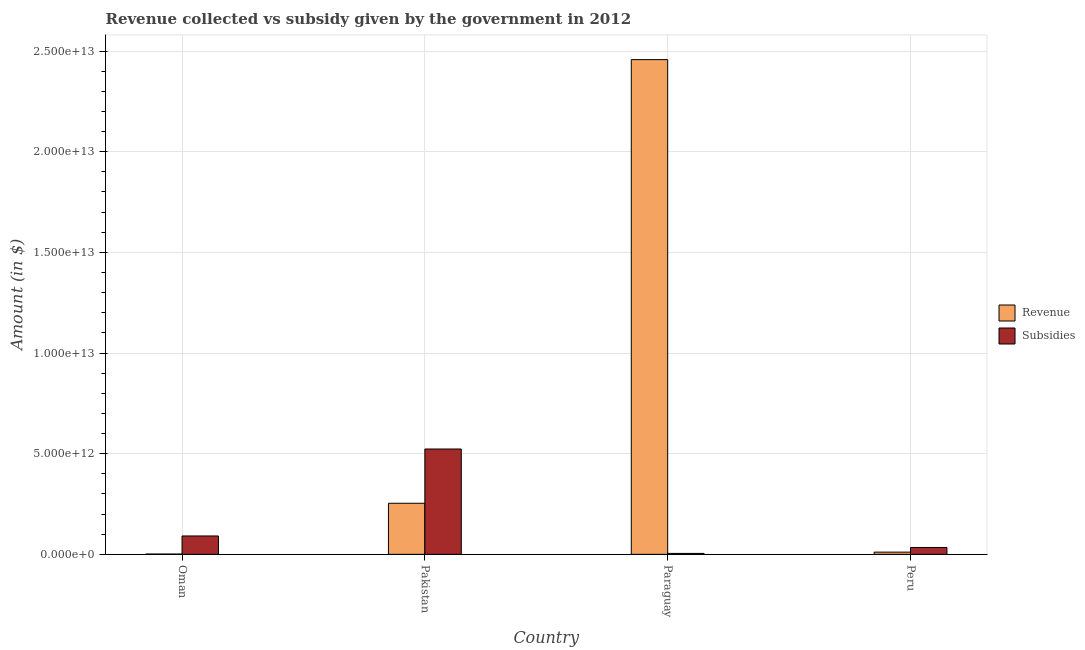Are the number of bars per tick equal to the number of legend labels?
Provide a succinct answer. Yes. What is the label of the 2nd group of bars from the left?
Provide a short and direct response. Pakistan. In how many cases, is the number of bars for a given country not equal to the number of legend labels?
Give a very brief answer. 0. What is the amount of revenue collected in Oman?
Your response must be concise. 1.34e+1. Across all countries, what is the maximum amount of subsidies given?
Offer a terse response. 5.23e+12. Across all countries, what is the minimum amount of revenue collected?
Make the answer very short. 1.34e+1. In which country was the amount of revenue collected maximum?
Your answer should be compact. Paraguay. In which country was the amount of subsidies given minimum?
Give a very brief answer. Paraguay. What is the total amount of subsidies given in the graph?
Provide a succinct answer. 6.53e+12. What is the difference between the amount of subsidies given in Paraguay and that in Peru?
Make the answer very short. -2.96e+11. What is the difference between the amount of revenue collected in Paraguay and the amount of subsidies given in Peru?
Your response must be concise. 2.42e+13. What is the average amount of subsidies given per country?
Offer a very short reply. 1.63e+12. What is the difference between the amount of revenue collected and amount of subsidies given in Oman?
Your answer should be compact. -8.99e+11. In how many countries, is the amount of revenue collected greater than 15000000000000 $?
Your answer should be compact. 1. What is the ratio of the amount of subsidies given in Paraguay to that in Peru?
Your answer should be compact. 0.13. Is the amount of subsidies given in Paraguay less than that in Peru?
Provide a short and direct response. Yes. What is the difference between the highest and the second highest amount of revenue collected?
Provide a short and direct response. 2.20e+13. What is the difference between the highest and the lowest amount of subsidies given?
Offer a very short reply. 5.19e+12. What does the 1st bar from the left in Oman represents?
Your response must be concise. Revenue. What does the 1st bar from the right in Paraguay represents?
Make the answer very short. Subsidies. How many bars are there?
Keep it short and to the point. 8. How many countries are there in the graph?
Make the answer very short. 4. What is the difference between two consecutive major ticks on the Y-axis?
Provide a succinct answer. 5.00e+12. Does the graph contain any zero values?
Make the answer very short. No. How many legend labels are there?
Make the answer very short. 2. How are the legend labels stacked?
Provide a short and direct response. Vertical. What is the title of the graph?
Your answer should be compact. Revenue collected vs subsidy given by the government in 2012. Does "Nonresident" appear as one of the legend labels in the graph?
Provide a short and direct response. No. What is the label or title of the X-axis?
Ensure brevity in your answer.  Country. What is the label or title of the Y-axis?
Keep it short and to the point. Amount (in $). What is the Amount (in $) of Revenue in Oman?
Your answer should be compact. 1.34e+1. What is the Amount (in $) in Subsidies in Oman?
Your answer should be very brief. 9.13e+11. What is the Amount (in $) in Revenue in Pakistan?
Your answer should be very brief. 2.54e+12. What is the Amount (in $) in Subsidies in Pakistan?
Give a very brief answer. 5.23e+12. What is the Amount (in $) of Revenue in Paraguay?
Give a very brief answer. 2.46e+13. What is the Amount (in $) of Subsidies in Paraguay?
Your response must be concise. 4.53e+1. What is the Amount (in $) in Revenue in Peru?
Your answer should be compact. 1.09e+11. What is the Amount (in $) in Subsidies in Peru?
Ensure brevity in your answer.  3.41e+11. Across all countries, what is the maximum Amount (in $) in Revenue?
Give a very brief answer. 2.46e+13. Across all countries, what is the maximum Amount (in $) of Subsidies?
Your response must be concise. 5.23e+12. Across all countries, what is the minimum Amount (in $) of Revenue?
Provide a succinct answer. 1.34e+1. Across all countries, what is the minimum Amount (in $) in Subsidies?
Offer a very short reply. 4.53e+1. What is the total Amount (in $) of Revenue in the graph?
Offer a terse response. 2.72e+13. What is the total Amount (in $) in Subsidies in the graph?
Provide a succinct answer. 6.53e+12. What is the difference between the Amount (in $) of Revenue in Oman and that in Pakistan?
Make the answer very short. -2.52e+12. What is the difference between the Amount (in $) in Subsidies in Oman and that in Pakistan?
Your answer should be compact. -4.32e+12. What is the difference between the Amount (in $) of Revenue in Oman and that in Paraguay?
Your answer should be very brief. -2.46e+13. What is the difference between the Amount (in $) of Subsidies in Oman and that in Paraguay?
Your answer should be compact. 8.67e+11. What is the difference between the Amount (in $) in Revenue in Oman and that in Peru?
Offer a very short reply. -9.59e+1. What is the difference between the Amount (in $) of Subsidies in Oman and that in Peru?
Your answer should be compact. 5.72e+11. What is the difference between the Amount (in $) of Revenue in Pakistan and that in Paraguay?
Provide a succinct answer. -2.20e+13. What is the difference between the Amount (in $) in Subsidies in Pakistan and that in Paraguay?
Offer a very short reply. 5.19e+12. What is the difference between the Amount (in $) of Revenue in Pakistan and that in Peru?
Your response must be concise. 2.43e+12. What is the difference between the Amount (in $) in Subsidies in Pakistan and that in Peru?
Your answer should be very brief. 4.89e+12. What is the difference between the Amount (in $) of Revenue in Paraguay and that in Peru?
Make the answer very short. 2.45e+13. What is the difference between the Amount (in $) in Subsidies in Paraguay and that in Peru?
Your answer should be compact. -2.96e+11. What is the difference between the Amount (in $) of Revenue in Oman and the Amount (in $) of Subsidies in Pakistan?
Your response must be concise. -5.22e+12. What is the difference between the Amount (in $) of Revenue in Oman and the Amount (in $) of Subsidies in Paraguay?
Offer a terse response. -3.18e+1. What is the difference between the Amount (in $) in Revenue in Oman and the Amount (in $) in Subsidies in Peru?
Your answer should be very brief. -3.28e+11. What is the difference between the Amount (in $) of Revenue in Pakistan and the Amount (in $) of Subsidies in Paraguay?
Your response must be concise. 2.49e+12. What is the difference between the Amount (in $) of Revenue in Pakistan and the Amount (in $) of Subsidies in Peru?
Provide a succinct answer. 2.20e+12. What is the difference between the Amount (in $) of Revenue in Paraguay and the Amount (in $) of Subsidies in Peru?
Your answer should be very brief. 2.42e+13. What is the average Amount (in $) in Revenue per country?
Keep it short and to the point. 6.81e+12. What is the average Amount (in $) in Subsidies per country?
Your answer should be very brief. 1.63e+12. What is the difference between the Amount (in $) of Revenue and Amount (in $) of Subsidies in Oman?
Ensure brevity in your answer.  -8.99e+11. What is the difference between the Amount (in $) of Revenue and Amount (in $) of Subsidies in Pakistan?
Offer a terse response. -2.70e+12. What is the difference between the Amount (in $) in Revenue and Amount (in $) in Subsidies in Paraguay?
Your answer should be very brief. 2.45e+13. What is the difference between the Amount (in $) in Revenue and Amount (in $) in Subsidies in Peru?
Offer a terse response. -2.32e+11. What is the ratio of the Amount (in $) of Revenue in Oman to that in Pakistan?
Offer a terse response. 0.01. What is the ratio of the Amount (in $) in Subsidies in Oman to that in Pakistan?
Your answer should be compact. 0.17. What is the ratio of the Amount (in $) of Revenue in Oman to that in Paraguay?
Provide a succinct answer. 0. What is the ratio of the Amount (in $) of Subsidies in Oman to that in Paraguay?
Offer a very short reply. 20.16. What is the ratio of the Amount (in $) of Revenue in Oman to that in Peru?
Your response must be concise. 0.12. What is the ratio of the Amount (in $) in Subsidies in Oman to that in Peru?
Provide a short and direct response. 2.68. What is the ratio of the Amount (in $) in Revenue in Pakistan to that in Paraguay?
Give a very brief answer. 0.1. What is the ratio of the Amount (in $) of Subsidies in Pakistan to that in Paraguay?
Your response must be concise. 115.56. What is the ratio of the Amount (in $) in Revenue in Pakistan to that in Peru?
Your answer should be compact. 23.21. What is the ratio of the Amount (in $) in Subsidies in Pakistan to that in Peru?
Keep it short and to the point. 15.34. What is the ratio of the Amount (in $) in Revenue in Paraguay to that in Peru?
Make the answer very short. 224.81. What is the ratio of the Amount (in $) of Subsidies in Paraguay to that in Peru?
Provide a short and direct response. 0.13. What is the difference between the highest and the second highest Amount (in $) in Revenue?
Offer a very short reply. 2.20e+13. What is the difference between the highest and the second highest Amount (in $) in Subsidies?
Offer a very short reply. 4.32e+12. What is the difference between the highest and the lowest Amount (in $) in Revenue?
Give a very brief answer. 2.46e+13. What is the difference between the highest and the lowest Amount (in $) in Subsidies?
Keep it short and to the point. 5.19e+12. 